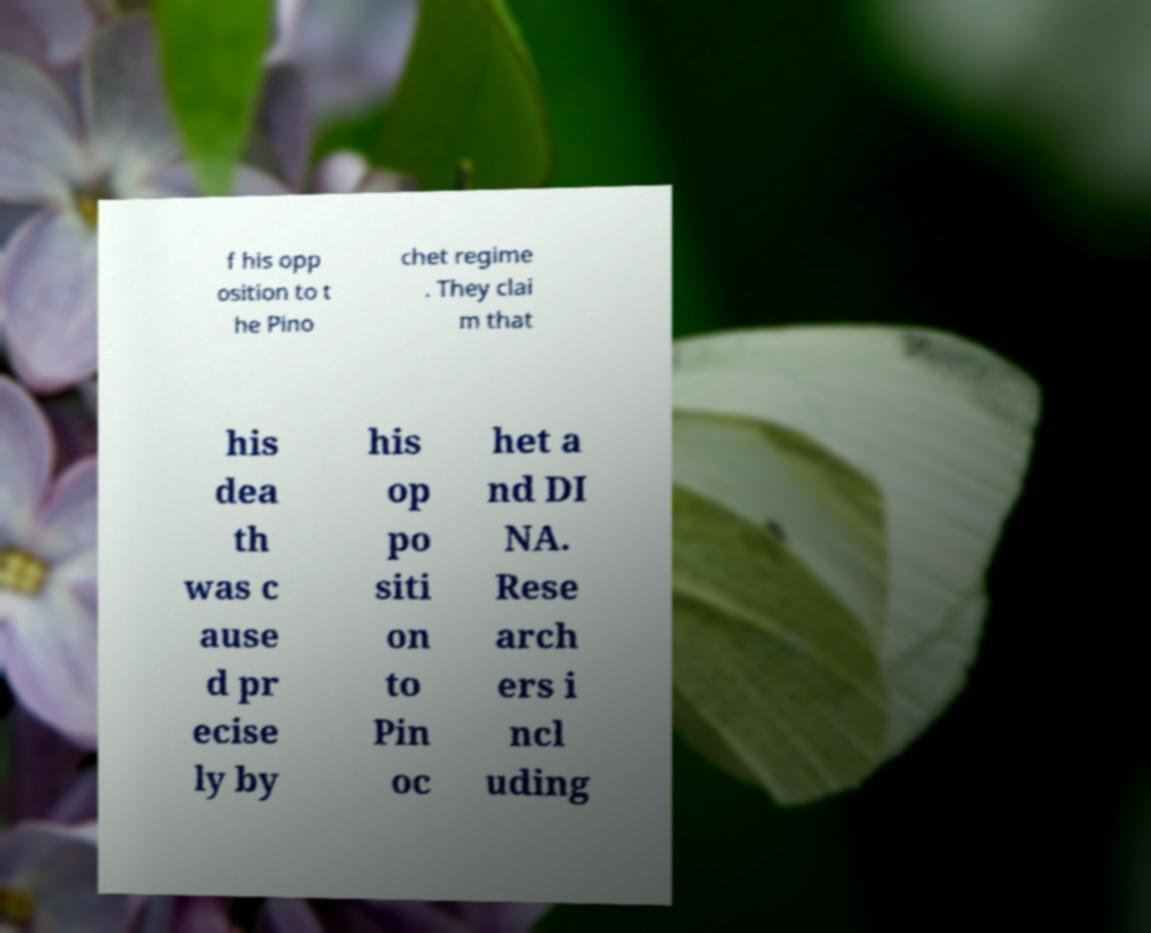Could you extract and type out the text from this image? f his opp osition to t he Pino chet regime . They clai m that his dea th was c ause d pr ecise ly by his op po siti on to Pin oc het a nd DI NA. Rese arch ers i ncl uding 